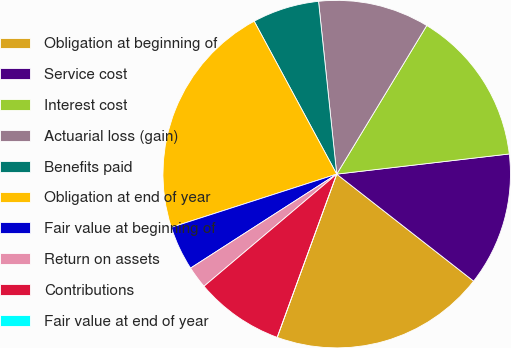<chart> <loc_0><loc_0><loc_500><loc_500><pie_chart><fcel>Obligation at beginning of<fcel>Service cost<fcel>Interest cost<fcel>Actuarial loss (gain)<fcel>Benefits paid<fcel>Obligation at end of year<fcel>Fair value at beginning of<fcel>Return on assets<fcel>Contributions<fcel>Fair value at end of year<nl><fcel>20.01%<fcel>12.41%<fcel>14.48%<fcel>10.34%<fcel>6.21%<fcel>22.08%<fcel>4.14%<fcel>2.07%<fcel>8.27%<fcel>0.0%<nl></chart> 